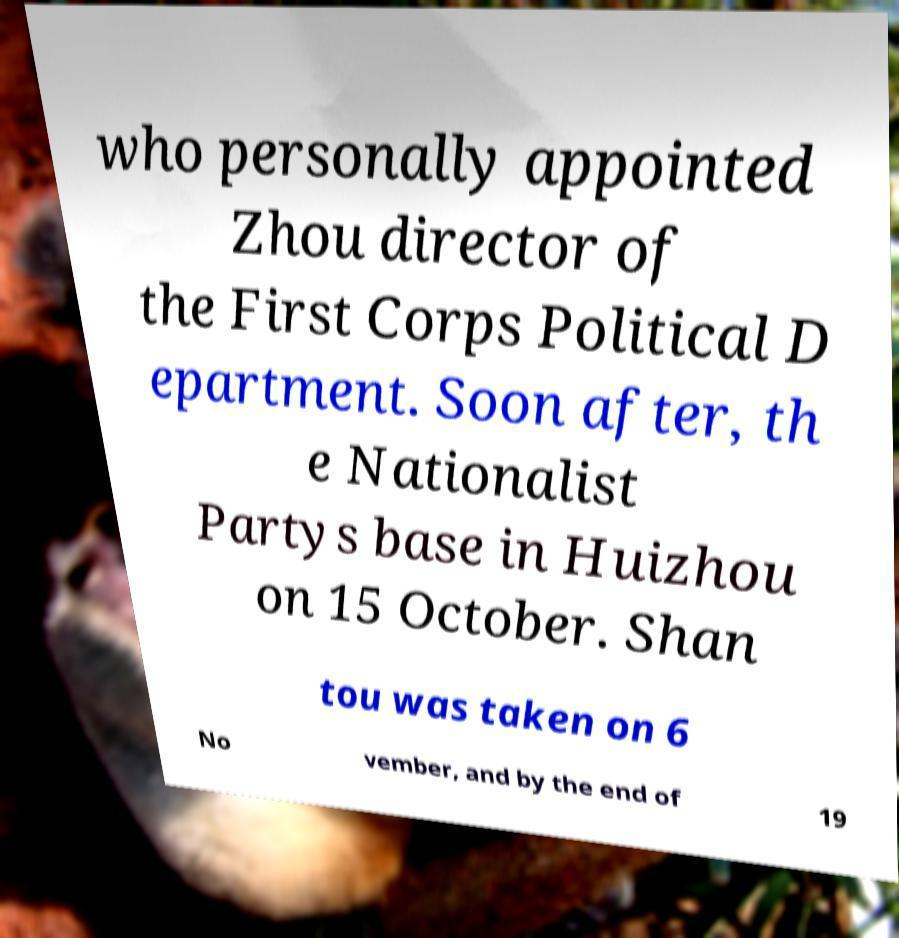Could you extract and type out the text from this image? who personally appointed Zhou director of the First Corps Political D epartment. Soon after, th e Nationalist Partys base in Huizhou on 15 October. Shan tou was taken on 6 No vember, and by the end of 19 